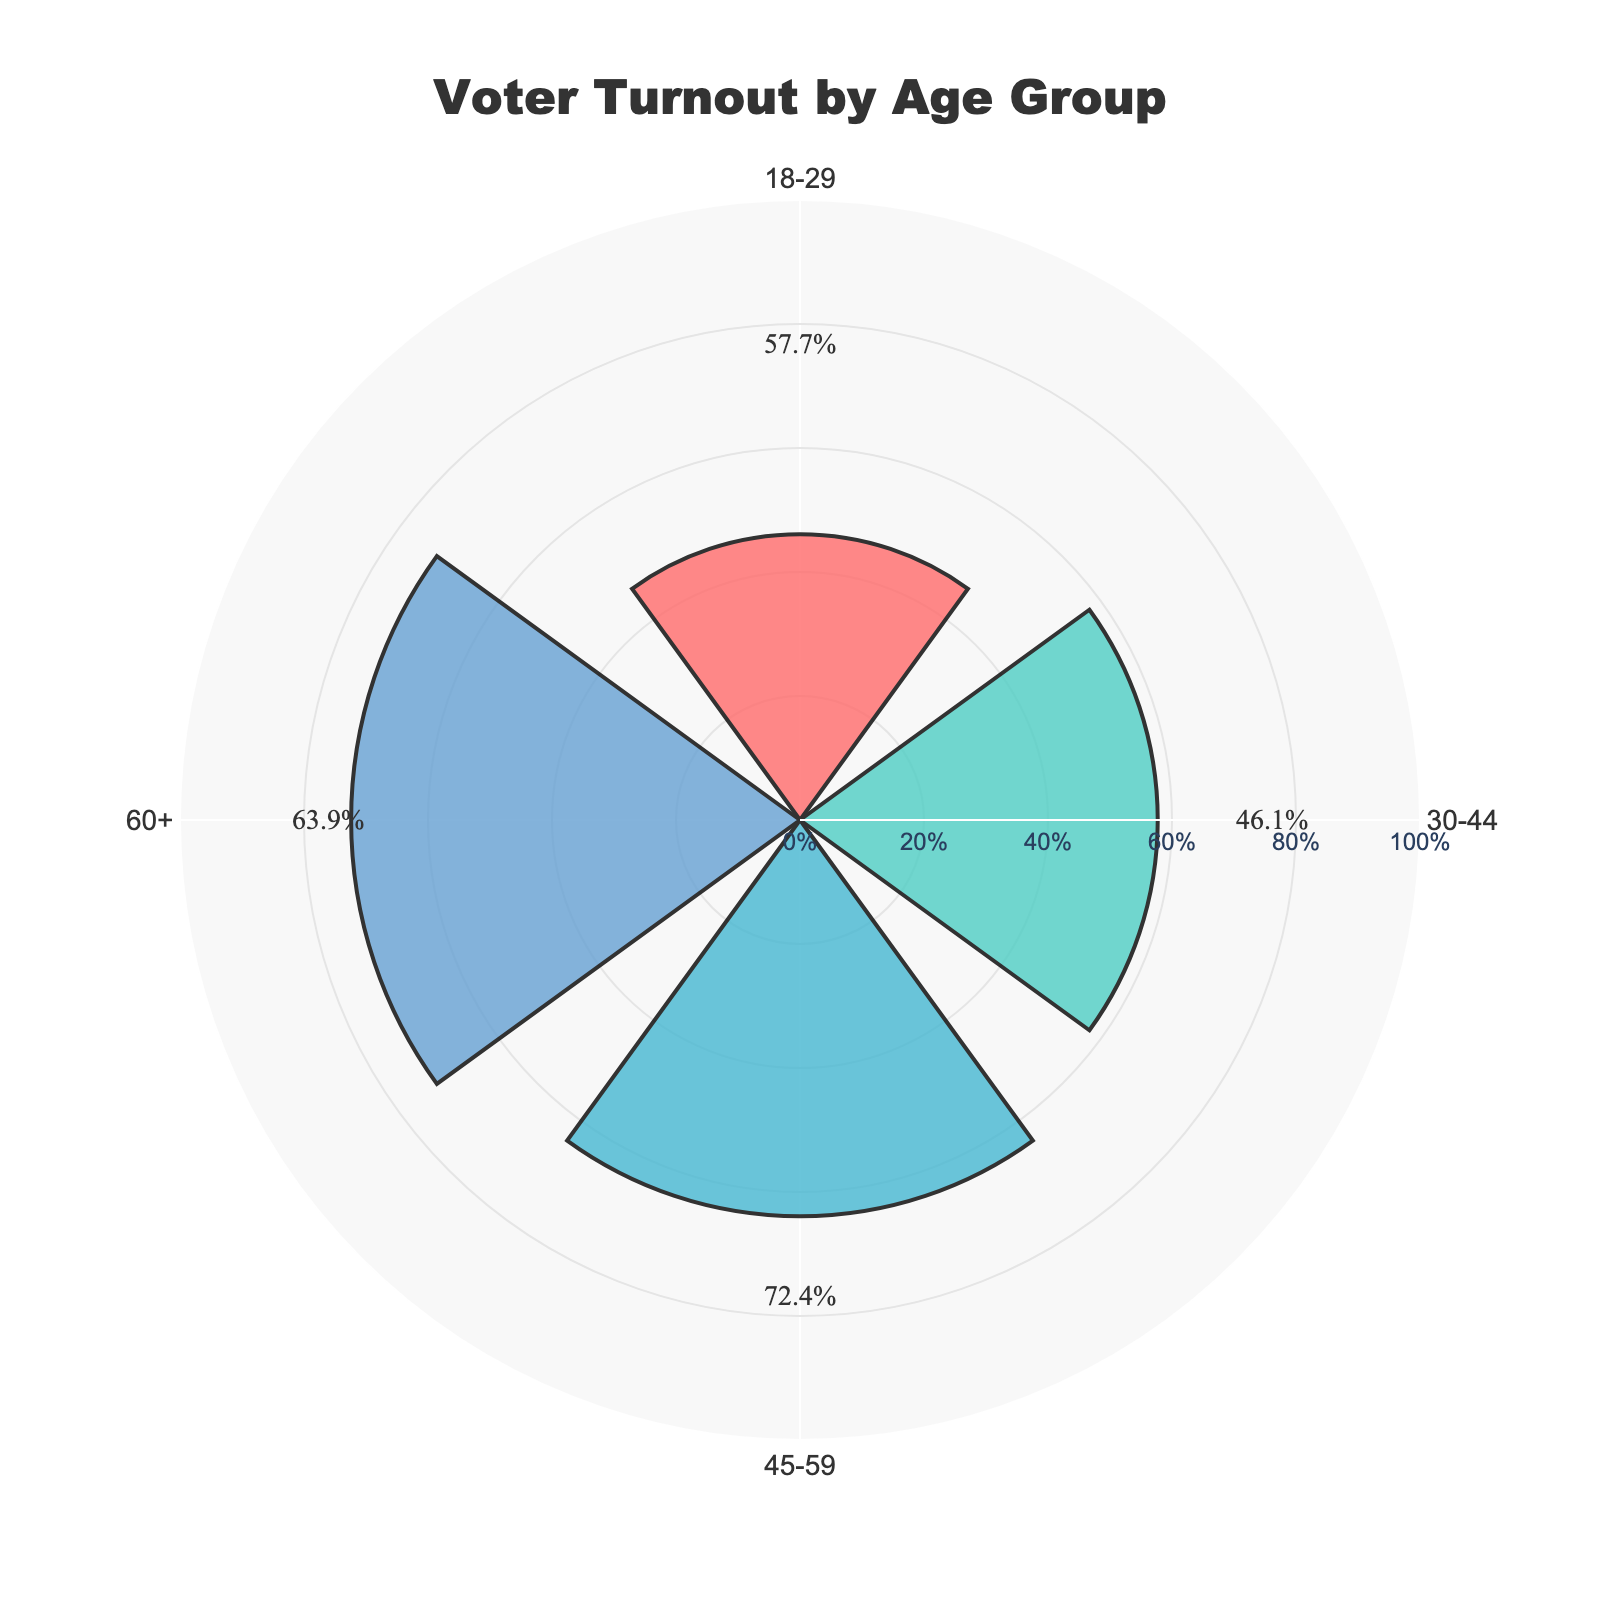What's the highest voter turnout percentage among the age groups? To find the highest percentage, look for the largest value on the chart. From the data, the "60+" age group has the highest voter turnout of 72.4%.
Answer: 72.4% Which age group has the lowest voter turnout? To determine the lowest voter turnout, identify the smallest value on the chart. The "18-29" age group has the lowest voter turnout of 46.1%.
Answer: 18-29 How many age groups are represented in the chart? The chart has labels for each age group segment. By counting the labels, there are four age groups: "18-29", "30-44", "45-59", and "60+".
Answer: 4 What is the average voter turnout percentage across all age groups? To find the average, add up the voter turnout percentages and divide by the number of groups. The percentages are 46.1, 57.7, 63.9, and 72.4. Sum them to get 240.1, then divide by 4 to get 60.025%.
Answer: 60.025% What is the difference in voter turnout between the "45-59" and "30-44" age groups? Subtract the voter turnout percentage of the "30-44" group from that of the "45-59" group. The turnout for "45-59" is 63.9% and for "30-44" is 57.7%. The difference is 63.9% - 57.7% = 6.2%.
Answer: 6.2% Which two consecutive age groups have the smallest difference in voter turnout? Compare the voter turnout differences between consecutive age groups: "18-29" to "30-44" is 57.7% - 46.1% = 11.6%, "30-44" to "45-59" is 63.9% - 57.7% = 6.2%, "45-59" to "60+" is 72.4% - 63.9% = 8.5%. The smallest difference is between "30-44" and "45-59", which is 6.2%.
Answer: 30-44 and 45-59 What is the combined voter turnout percentage for the "18-29" and "30-44" age groups? Add the voter turnout percentages of the "18-29" and "30-44" age groups. The values are 46.1% and 57.7%, respectively. Their combined voter turnout is 46.1% + 57.7% = 103.8%.
Answer: 103.8% How does the voter turnout of the "30-44" age group compare to the overall average? First, calculate the overall average turnout, which is 60.025%. The turnout for "30-44" is 57.7%. Since 57.7% is less than 60.025%, the "30-44" age group has a lower turnout than the average.
Answer: Lower Which age group shows the most significant increase in voter turnout compared to the previous group? Compare the differences between consecutive age groups' voter turnouts: "18-29" to "30-44" is 57.7% - 46.1% = 11.6%, "30-44" to "45-59" is 63.9% - 57.7% = 6.2%, "45-59" to "60+" is 72.4% - 63.9% = 8.5%. The most significant increase is from "18-29" to "30-44" with an 11.6% increase.
Answer: 18-29 to 30-44 